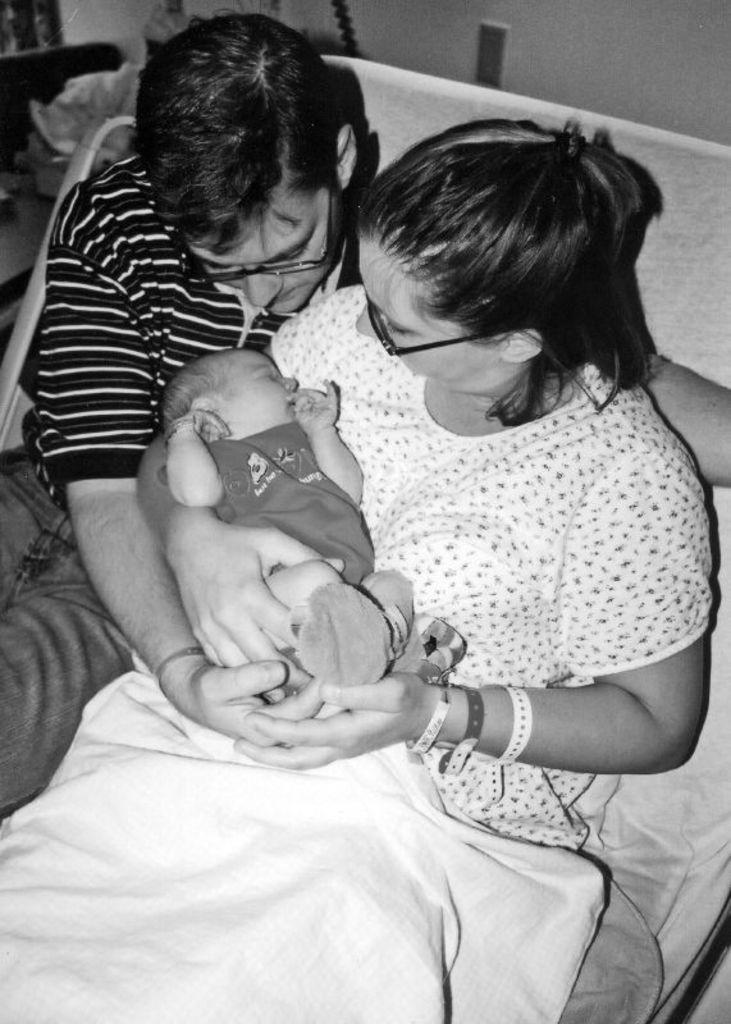How many people are present in the image? There are three people in the image: a man, a woman, and a baby. What is the baby doing in the image? The baby is lying on a bed sheet in the image. What can be seen in the background of the image? There is a wall in the background of the image. What type of prison is depicted in the image? There is no prison present in the image; it features a man, a woman, a baby, and a bed sheet. Are the sisters in the image wearing wax masks? There is no mention of sisters or wax masks in the image; it only features a man, a woman, a baby, and a bed sheet. 